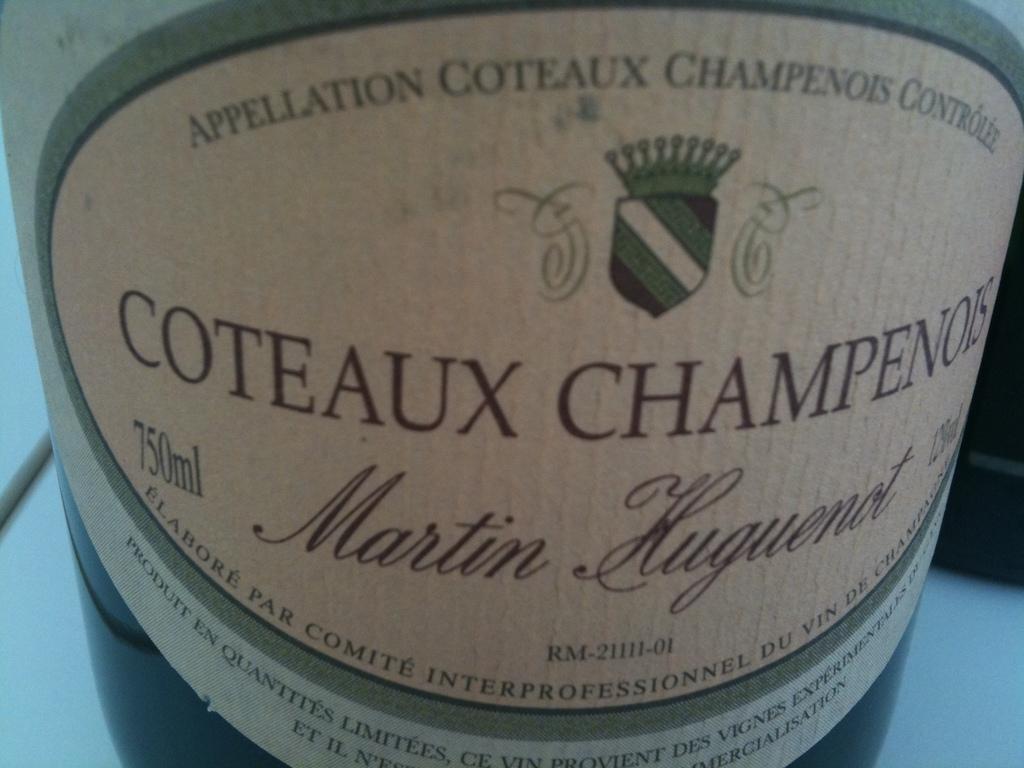How many ml can this hold?
Offer a very short reply. 750. What is the name of this drink?
Provide a succinct answer. Coteaux champenois. 